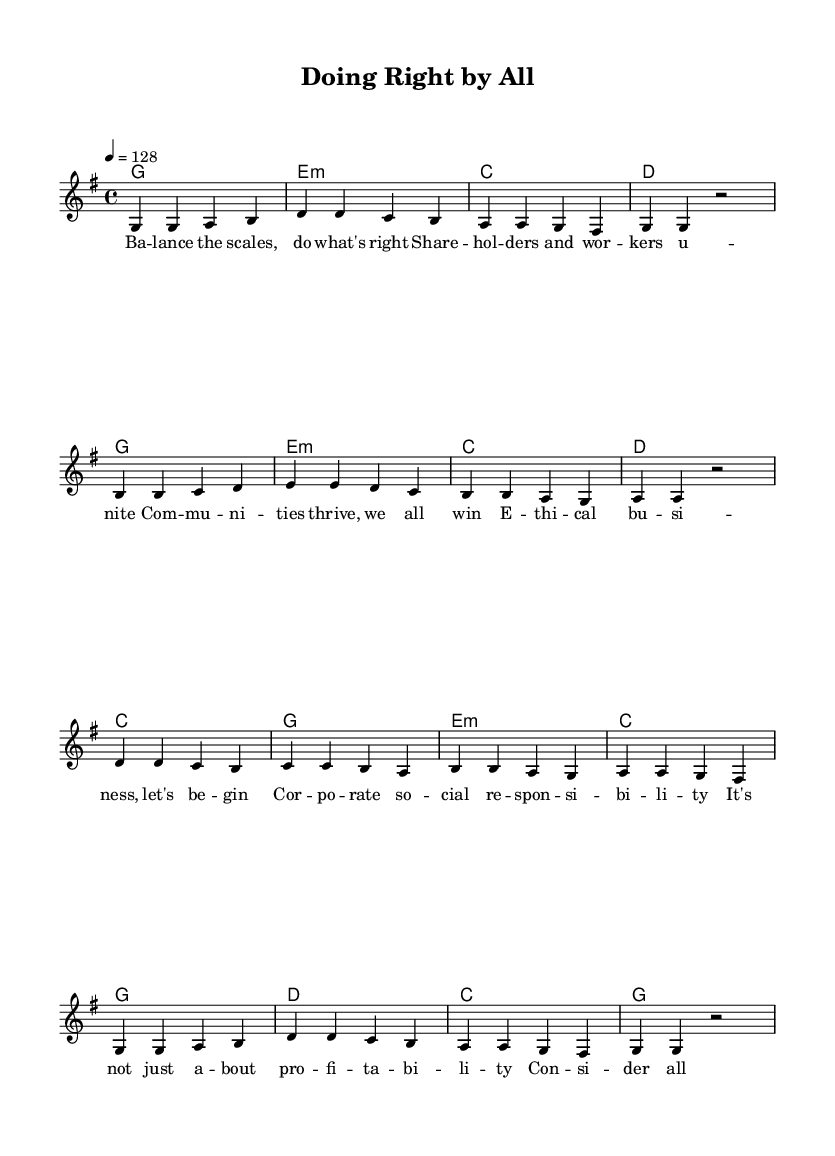What is the key signature of this music? The key signature is G major, which has one sharp (F#), indicated at the beginning of the staff.
Answer: G major What is the time signature of this piece? The time signature is 4/4, shown at the beginning of the score, indicating that there are four beats in each measure and a quarter note gets one beat.
Answer: 4/4 What is the tempo marking for this song? The tempo marking is 128 beats per minute, specified at the beginning with the indication "4 = 128".
Answer: 128 How many measures are in the melody section? By counting the measures, we find that there are a total of 16 measures in the melody section as divided by the vertical bar lines.
Answer: 16 What phrase indicates the theme of corporate social responsibility in the lyrics? The phrase "Ethical business, let's begin" clearly reflects the theme of ethical practices in business, emphasizing the importance of moral responsibility.
Answer: Ethical business, let's begin How do the harmonies change after the first verse? The harmonies transition from the initial key of G major to involve a progression through E minor, C major, and D major throughout the subsequent phrases, which adds musical variety.
Answer: G, E minor, C, D Which chord follows the "communities thrive" lyric? After the lyric "Communities thrive, we all win", the following chord is E minor, which indicates the tonal shift and complements the lyrical theme of community success.
Answer: E minor 